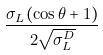Convert formula to latex. <formula><loc_0><loc_0><loc_500><loc_500>\frac { \sigma _ { L } ( \cos \theta + 1 ) } { 2 \sqrt { \sigma _ { L } ^ { D } } }</formula> 